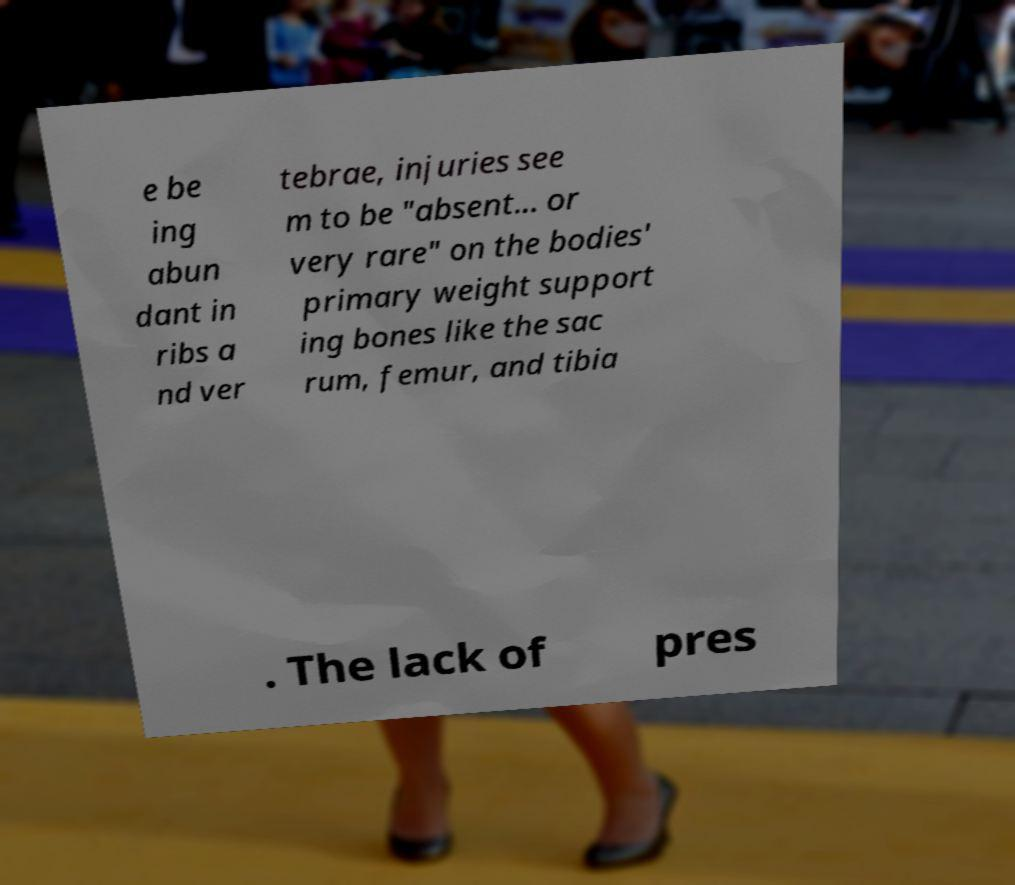Please identify and transcribe the text found in this image. e be ing abun dant in ribs a nd ver tebrae, injuries see m to be "absent... or very rare" on the bodies' primary weight support ing bones like the sac rum, femur, and tibia . The lack of pres 